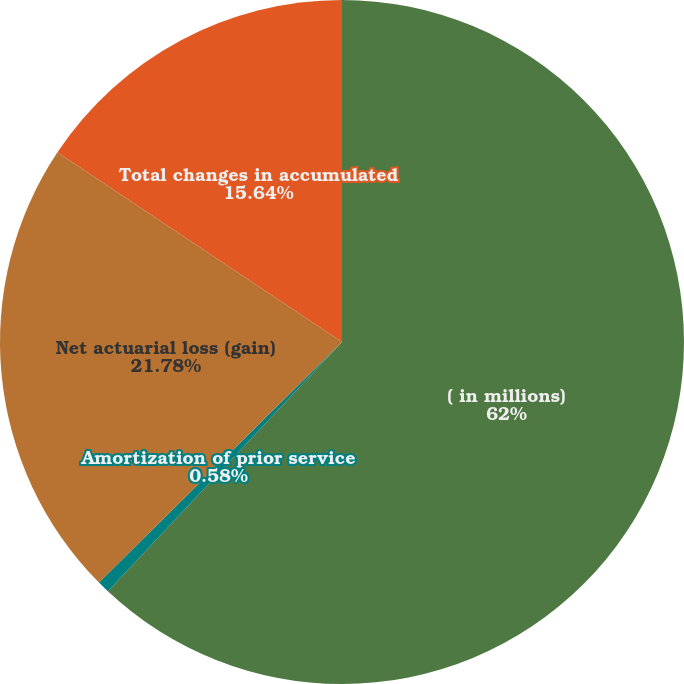Convert chart to OTSL. <chart><loc_0><loc_0><loc_500><loc_500><pie_chart><fcel>( in millions)<fcel>Amortization of prior service<fcel>Net actuarial loss (gain)<fcel>Total changes in accumulated<nl><fcel>62.0%<fcel>0.58%<fcel>21.78%<fcel>15.64%<nl></chart> 